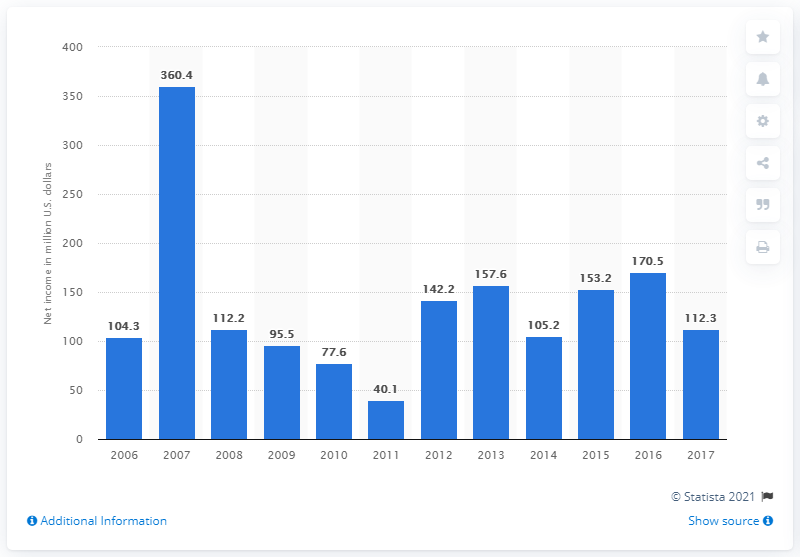Identify some key points in this picture. Regal Entertainment Group's net profit in 2017 was 112.3 million dollars. 